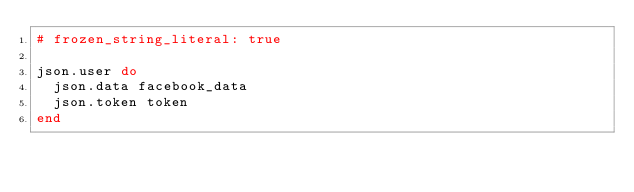Convert code to text. <code><loc_0><loc_0><loc_500><loc_500><_Ruby_># frozen_string_literal: true

json.user do
  json.data facebook_data
  json.token token
end
</code> 